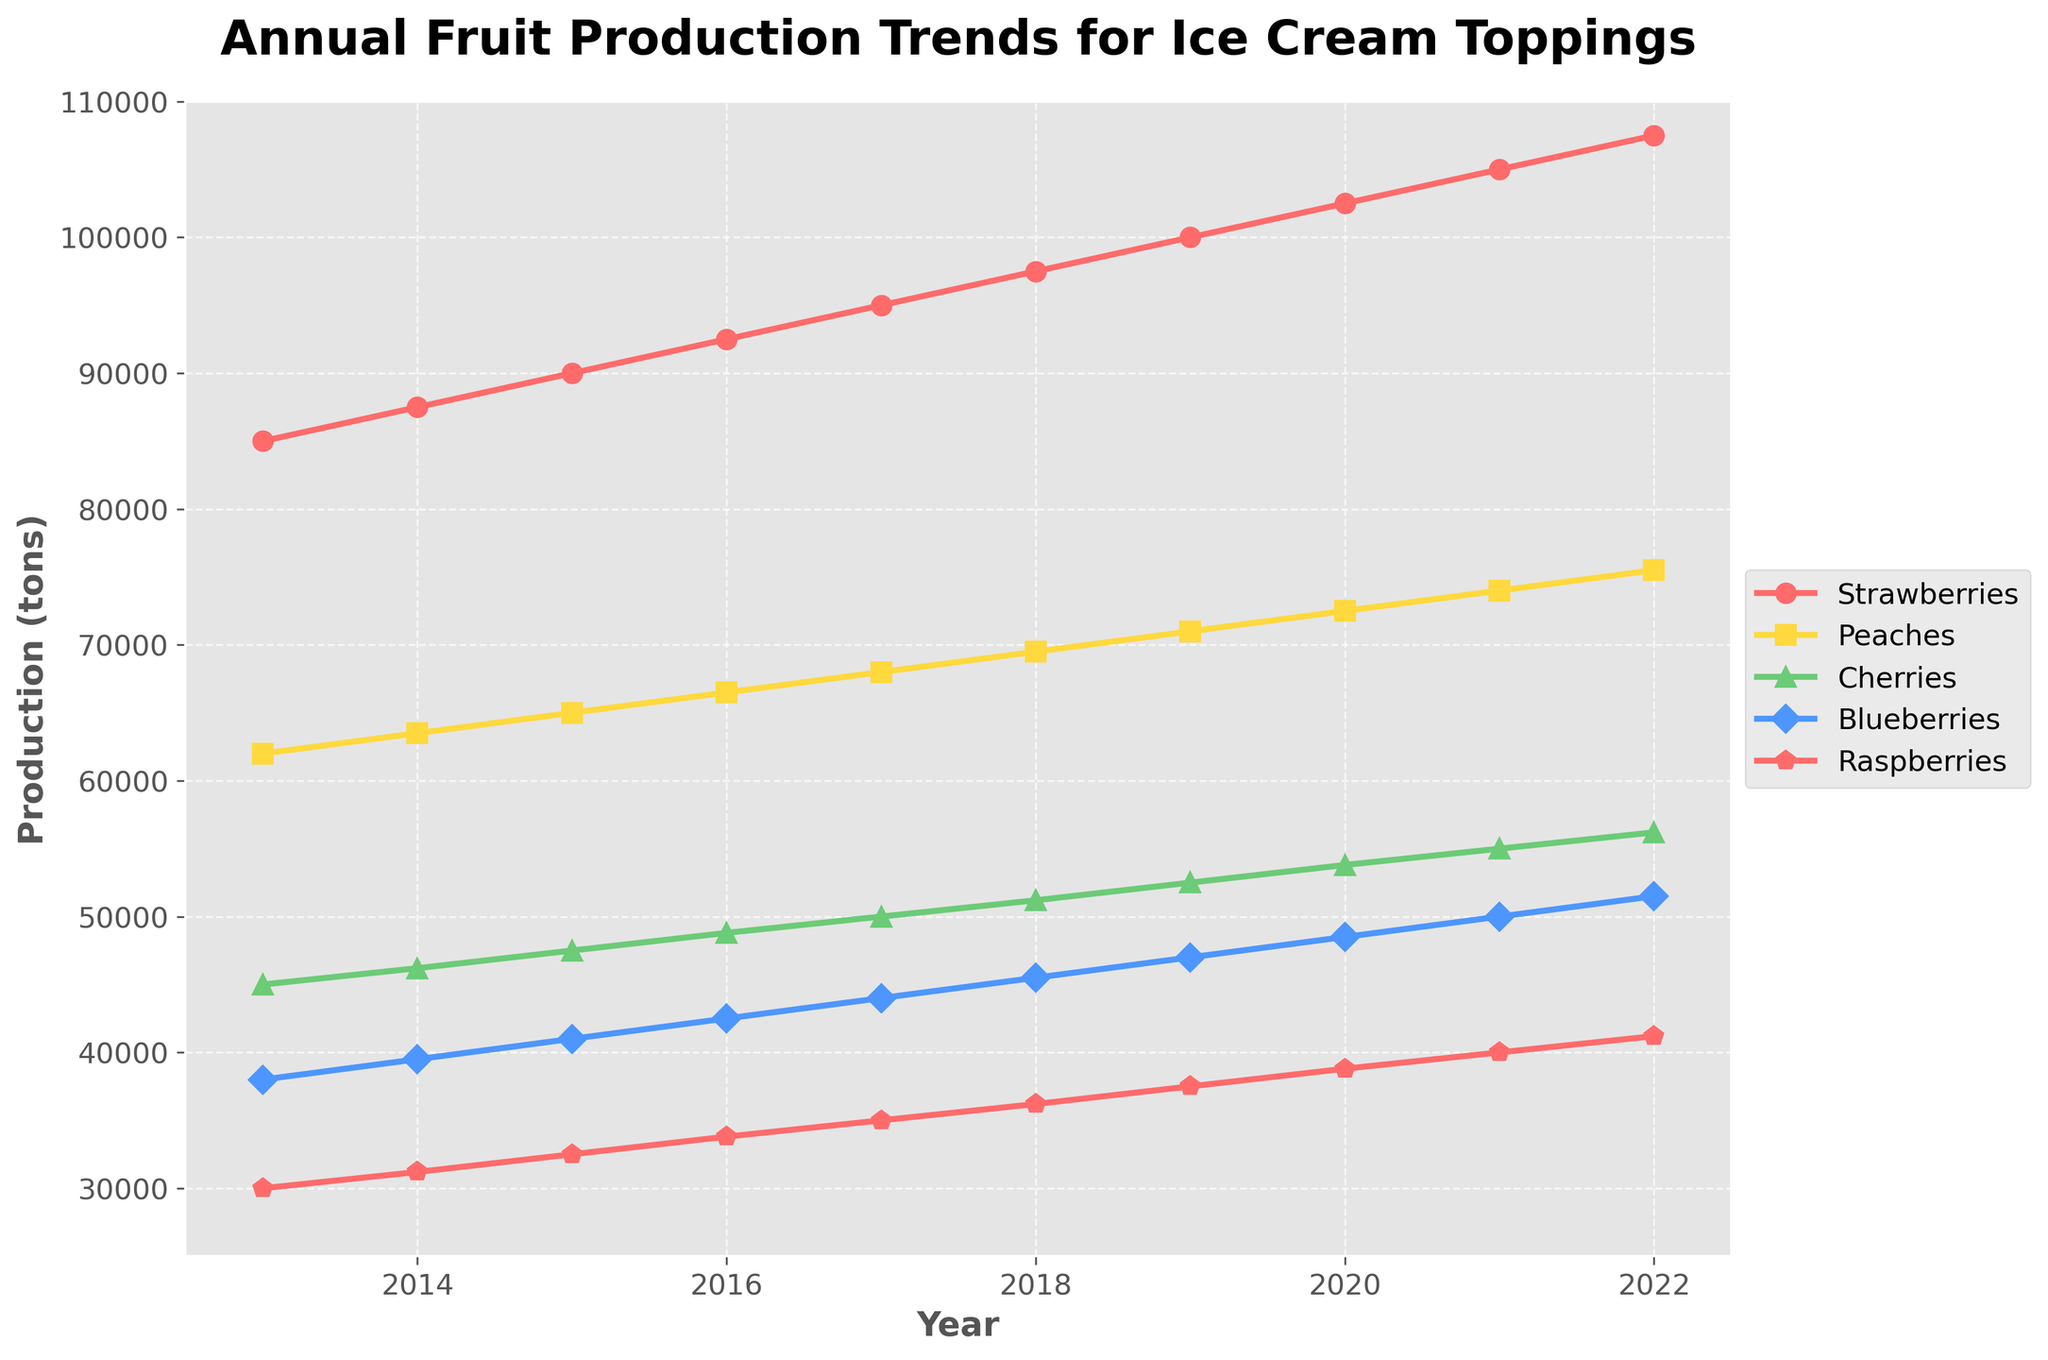What fruit had the highest production in 2020? From the figure, look for the year 2020 along the x-axis and find the highest point among the lines representing different fruits. Strawberries had the highest point.
Answer: Strawberries What is the average production of Raspberries from 2018 to 2022? Find the production data of Raspberries for the years 2018 to 2022 (36200, 37500, 38800, 40000, 41200), sum them up and divide by the number of years. The average is (36200 + 37500 + 38800 + 40000 + 41200)/5 = 38740
Answer: 38740 Which fruit had a greater increase in production from 2013 to 2017, Peaches or Cherries? Calculate the difference in production for both fruits between 2013 and 2017. Peaches: 68000 - 62000 = 6000, Cherries: 50000 - 45000 = 5000. Peaches had a greater increase.
Answer: Peaches What is the total fruit production for all fruits in 2019? Sum the production values of all five fruits in 2019: 100000 (Strawberries) + 71000 (Peaches) + 52500 (Cherries) + 47000 (Blueberries) + 37500 (Raspberries) = 308000
Answer: 308000 Which fruit shows a consistent increase in production over the years without any drop? From the figure, observe the trend lines of each fruit. Strawberries show a consistent increase without any drop from 2013 to 2022.
Answer: Strawberries How much more Blueberries were produced in 2022 compared to 2015? Find the production of Blueberries in 2015 and 2022, then calculate the difference. 51500 (2022) - 41000 (2015) = 10500
Answer: 10500 Which fruit had the steepest increase in production between 2019 and 2020? Identify the year 2019 to 2020 and see which fruit's line had the steepest slope. Strawberries increased from 100000 to 102500.
Answer: Strawberries How does the production of Raspberries in 2022 compare to that of Blueberries in 2016? Find the production values of Raspberries in 2022 (41200) and Blueberries in 2016 (42500). Blueberries in 2016 were greater than Raspberries in 2022.
Answer: Blueberries in 2016 What is the difference in production between Peaches and Cherries in 2018? Find the production values of Peaches (69500) and Cherries (51200) in 2018, then calculate the difference: 69500 - 51200 = 18300
Answer: 18300 Which fruit's production increased by exactly 5000 tons between any two consecutive years? Observe each fruit's line and calculate the yearly differences. Strawberries increased by exactly 5000 tons between 2021 and 2022.
Answer: Strawberries 